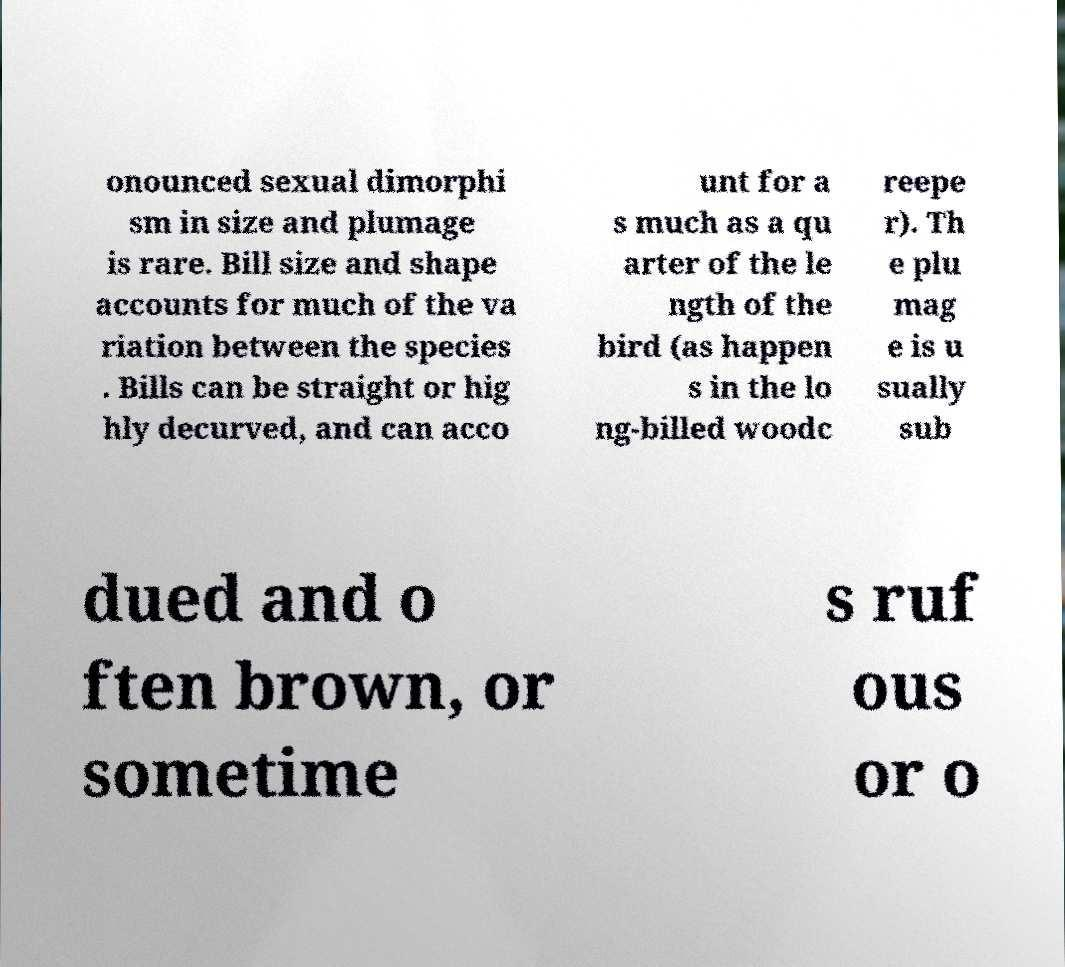Can you accurately transcribe the text from the provided image for me? onounced sexual dimorphi sm in size and plumage is rare. Bill size and shape accounts for much of the va riation between the species . Bills can be straight or hig hly decurved, and can acco unt for a s much as a qu arter of the le ngth of the bird (as happen s in the lo ng-billed woodc reepe r). Th e plu mag e is u sually sub dued and o ften brown, or sometime s ruf ous or o 